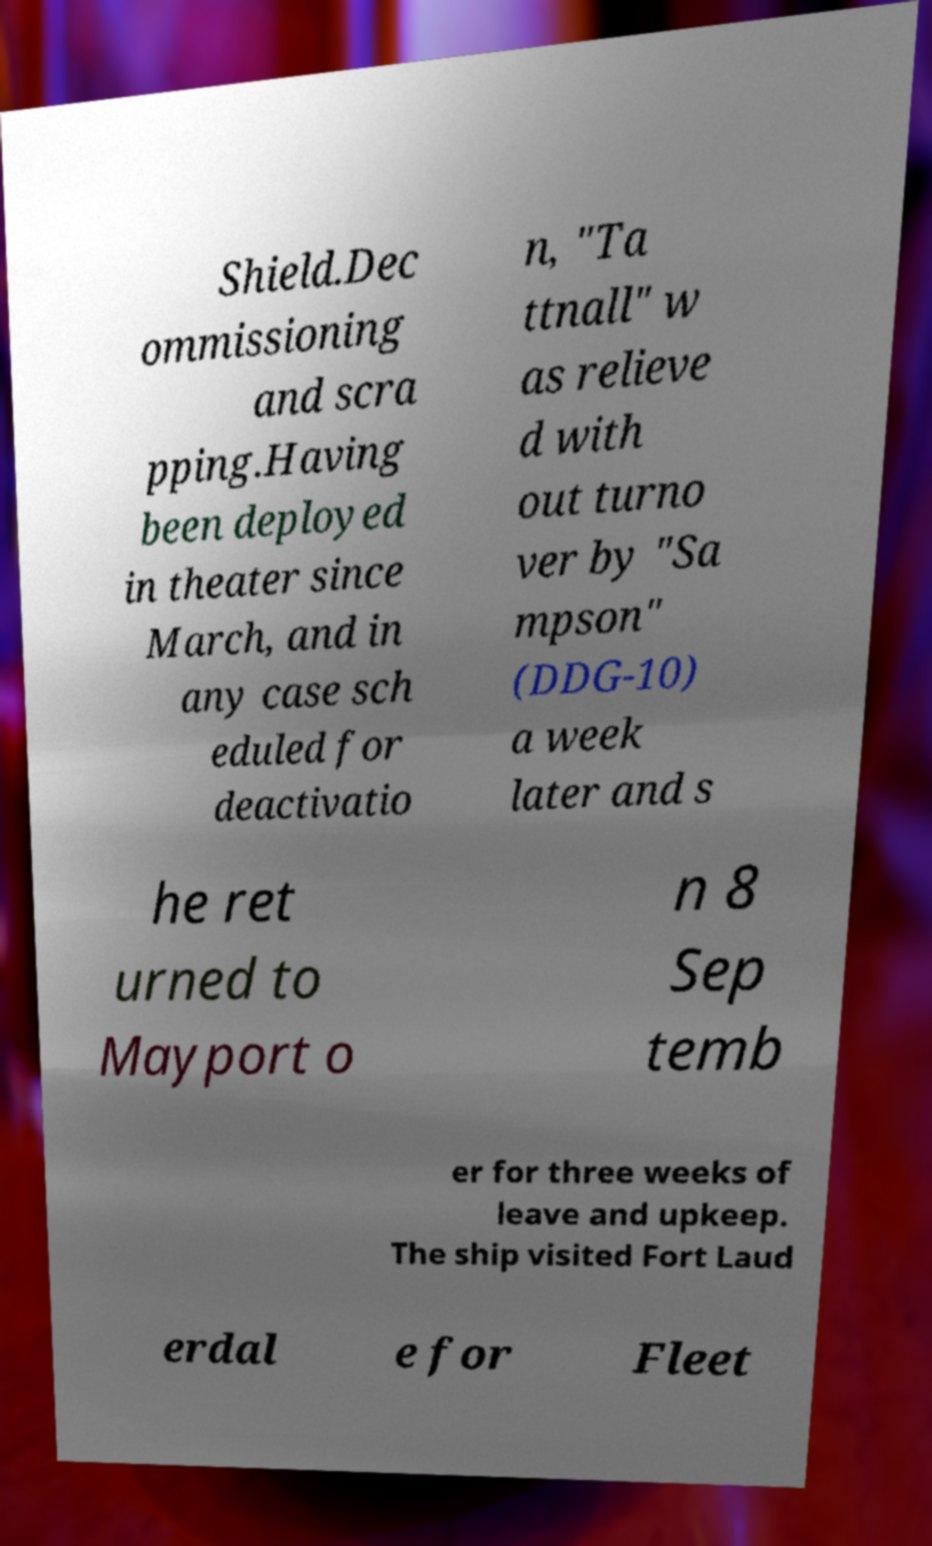For documentation purposes, I need the text within this image transcribed. Could you provide that? Shield.Dec ommissioning and scra pping.Having been deployed in theater since March, and in any case sch eduled for deactivatio n, "Ta ttnall" w as relieve d with out turno ver by "Sa mpson" (DDG-10) a week later and s he ret urned to Mayport o n 8 Sep temb er for three weeks of leave and upkeep. The ship visited Fort Laud erdal e for Fleet 